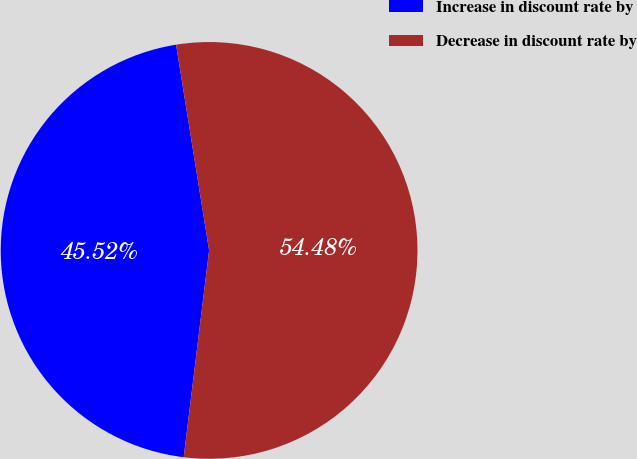Convert chart to OTSL. <chart><loc_0><loc_0><loc_500><loc_500><pie_chart><fcel>Increase in discount rate by<fcel>Decrease in discount rate by<nl><fcel>45.52%<fcel>54.48%<nl></chart> 